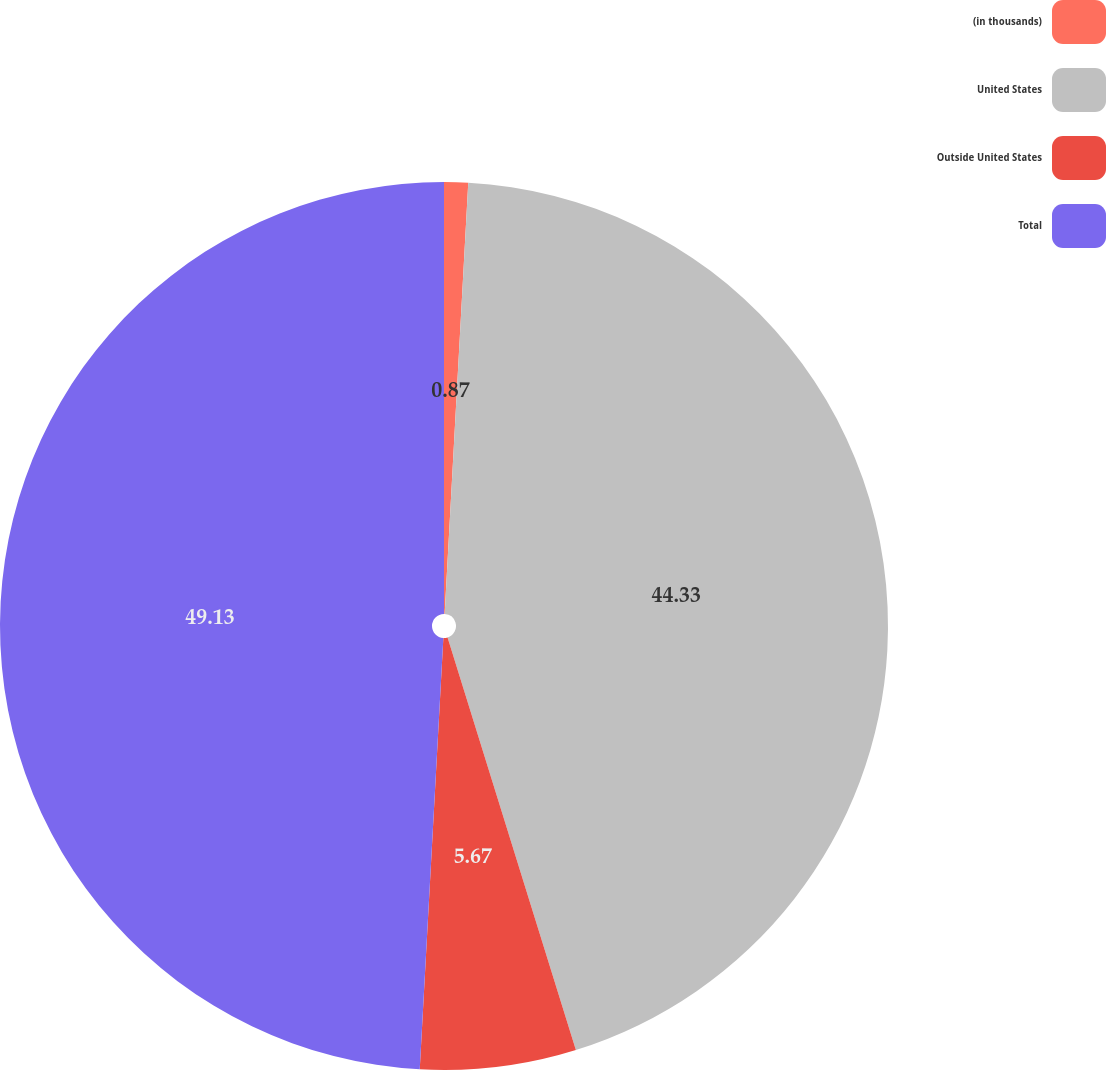<chart> <loc_0><loc_0><loc_500><loc_500><pie_chart><fcel>(in thousands)<fcel>United States<fcel>Outside United States<fcel>Total<nl><fcel>0.87%<fcel>44.33%<fcel>5.67%<fcel>49.13%<nl></chart> 